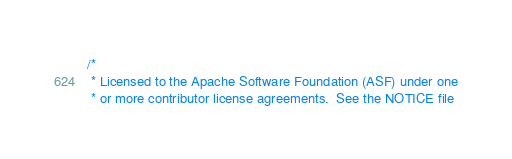Convert code to text. <code><loc_0><loc_0><loc_500><loc_500><_C++_>/*
 * Licensed to the Apache Software Foundation (ASF) under one
 * or more contributor license agreements.  See the NOTICE file</code> 